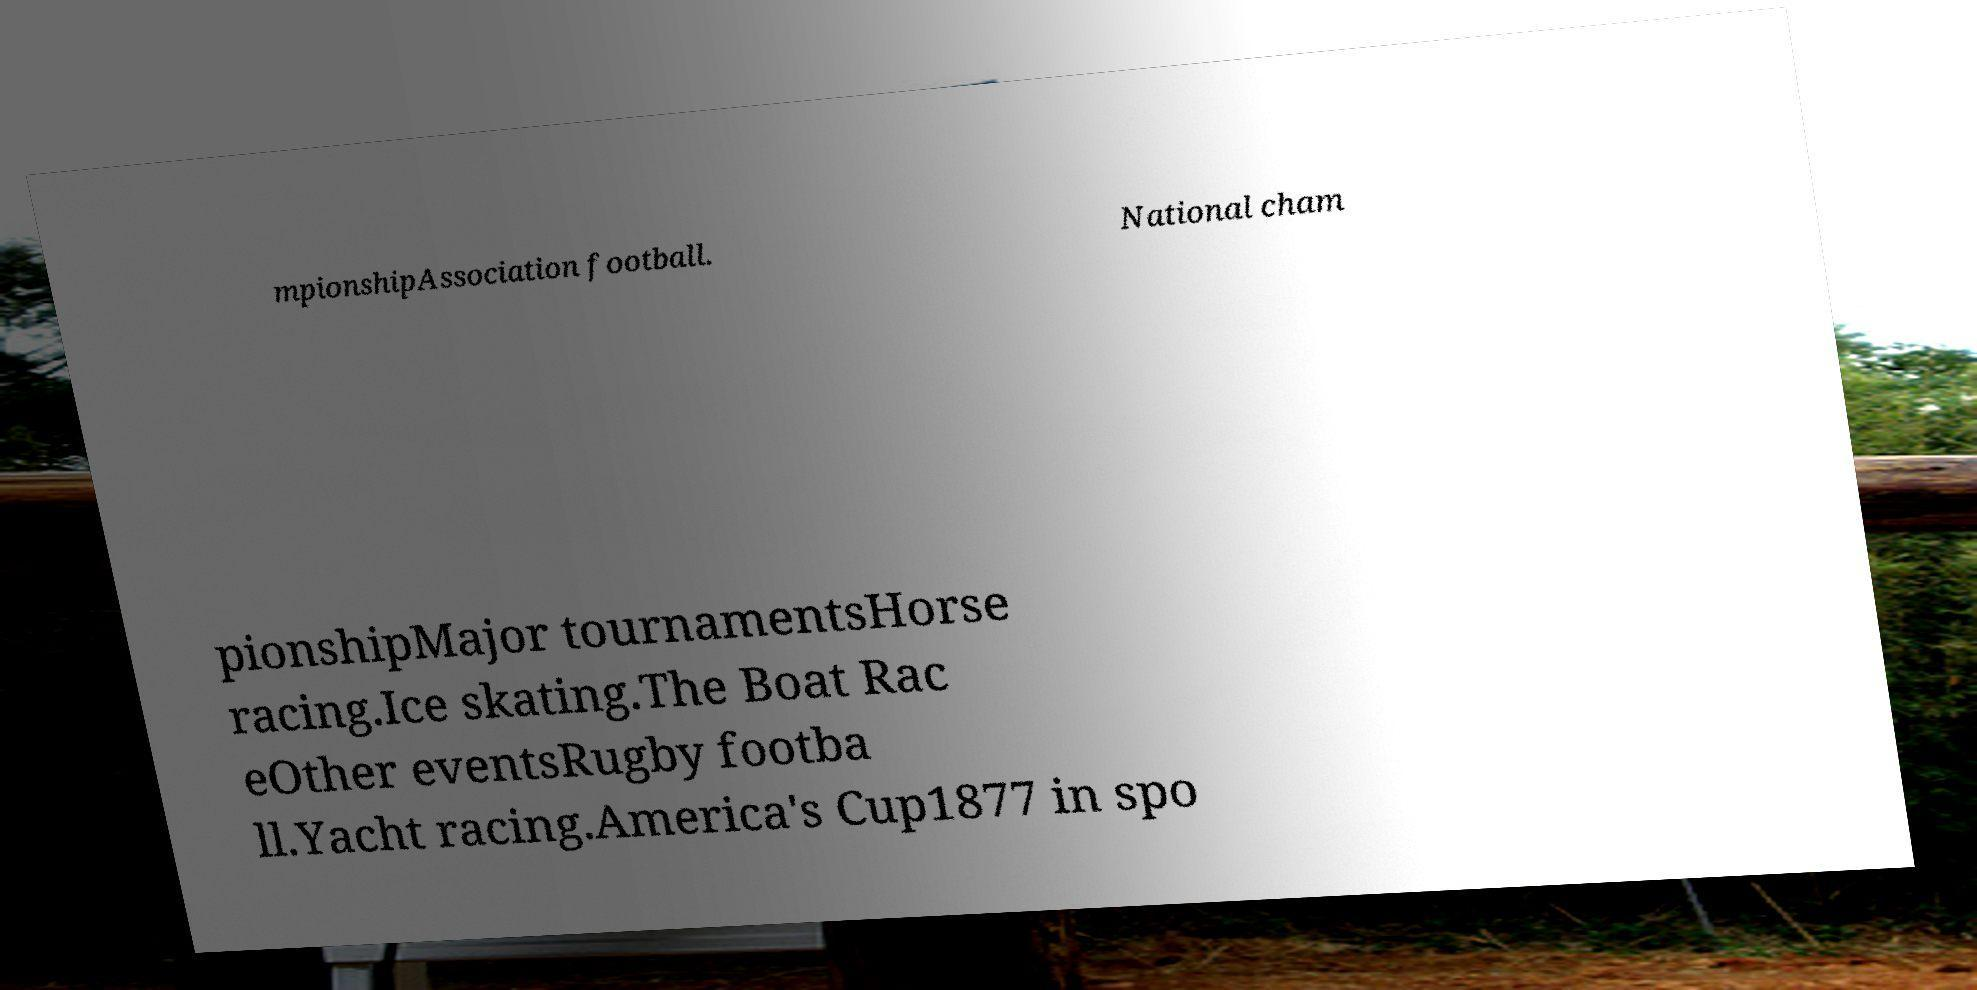There's text embedded in this image that I need extracted. Can you transcribe it verbatim? mpionshipAssociation football. National cham pionshipMajor tournamentsHorse racing.Ice skating.The Boat Rac eOther eventsRugby footba ll.Yacht racing.America's Cup1877 in spo 